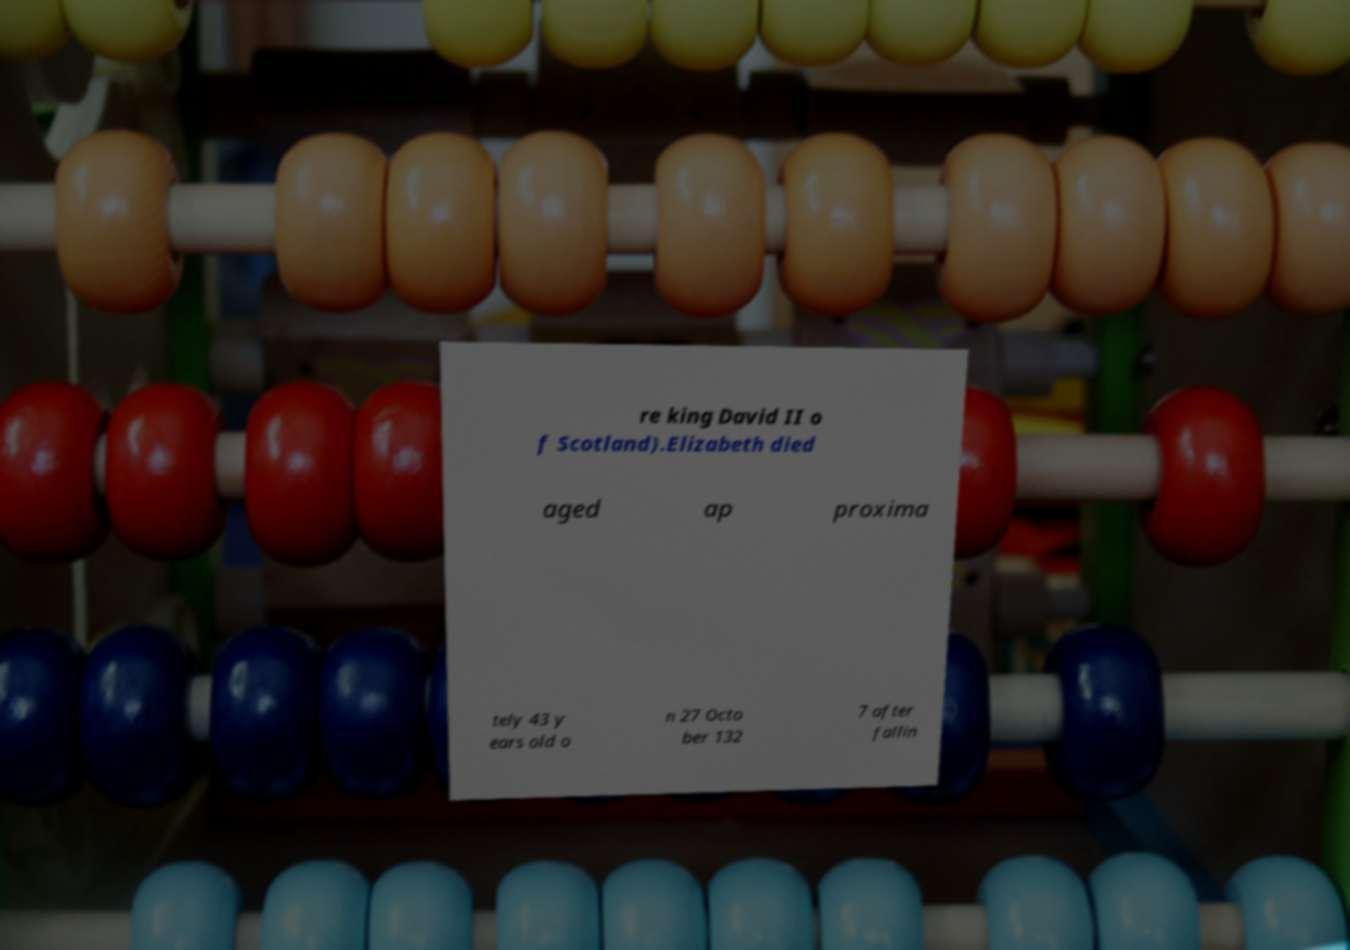Can you accurately transcribe the text from the provided image for me? re king David II o f Scotland).Elizabeth died aged ap proxima tely 43 y ears old o n 27 Octo ber 132 7 after fallin 